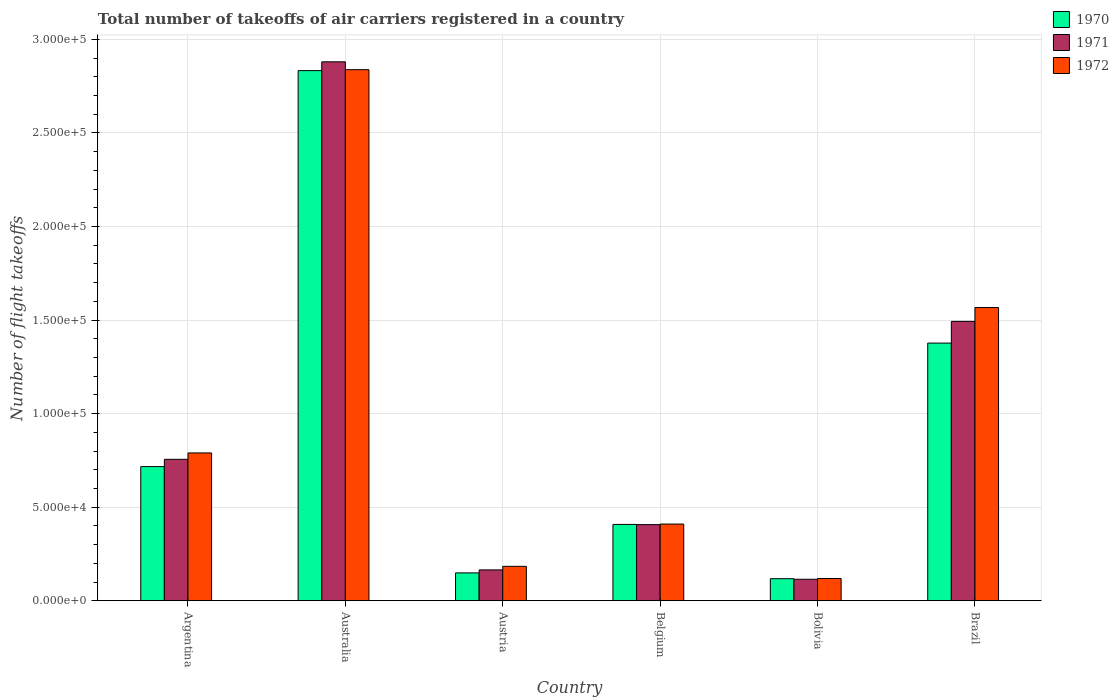How many groups of bars are there?
Your response must be concise. 6. What is the label of the 3rd group of bars from the left?
Your response must be concise. Austria. What is the total number of flight takeoffs in 1971 in Bolivia?
Offer a terse response. 1.15e+04. Across all countries, what is the maximum total number of flight takeoffs in 1970?
Offer a very short reply. 2.83e+05. Across all countries, what is the minimum total number of flight takeoffs in 1972?
Give a very brief answer. 1.19e+04. In which country was the total number of flight takeoffs in 1972 maximum?
Offer a terse response. Australia. In which country was the total number of flight takeoffs in 1971 minimum?
Provide a succinct answer. Bolivia. What is the total total number of flight takeoffs in 1972 in the graph?
Provide a short and direct response. 5.91e+05. What is the difference between the total number of flight takeoffs in 1971 in Austria and that in Brazil?
Your answer should be very brief. -1.33e+05. What is the difference between the total number of flight takeoffs in 1970 in Austria and the total number of flight takeoffs in 1971 in Belgium?
Give a very brief answer. -2.58e+04. What is the average total number of flight takeoffs in 1970 per country?
Your response must be concise. 9.34e+04. What is the difference between the total number of flight takeoffs of/in 1971 and total number of flight takeoffs of/in 1970 in Australia?
Ensure brevity in your answer.  4700. In how many countries, is the total number of flight takeoffs in 1970 greater than 260000?
Offer a very short reply. 1. What is the ratio of the total number of flight takeoffs in 1971 in Australia to that in Austria?
Make the answer very short. 17.45. Is the total number of flight takeoffs in 1971 in Austria less than that in Belgium?
Provide a short and direct response. Yes. What is the difference between the highest and the second highest total number of flight takeoffs in 1970?
Provide a succinct answer. -1.46e+05. What is the difference between the highest and the lowest total number of flight takeoffs in 1970?
Your answer should be compact. 2.72e+05. Is it the case that in every country, the sum of the total number of flight takeoffs in 1972 and total number of flight takeoffs in 1970 is greater than the total number of flight takeoffs in 1971?
Offer a very short reply. Yes. Are all the bars in the graph horizontal?
Give a very brief answer. No. Does the graph contain grids?
Offer a very short reply. Yes. Where does the legend appear in the graph?
Your answer should be compact. Top right. How many legend labels are there?
Your answer should be compact. 3. What is the title of the graph?
Provide a succinct answer. Total number of takeoffs of air carriers registered in a country. What is the label or title of the Y-axis?
Make the answer very short. Number of flight takeoffs. What is the Number of flight takeoffs in 1970 in Argentina?
Offer a terse response. 7.17e+04. What is the Number of flight takeoffs of 1971 in Argentina?
Ensure brevity in your answer.  7.56e+04. What is the Number of flight takeoffs in 1972 in Argentina?
Your response must be concise. 7.90e+04. What is the Number of flight takeoffs of 1970 in Australia?
Ensure brevity in your answer.  2.83e+05. What is the Number of flight takeoffs in 1971 in Australia?
Ensure brevity in your answer.  2.88e+05. What is the Number of flight takeoffs of 1972 in Australia?
Your response must be concise. 2.84e+05. What is the Number of flight takeoffs of 1970 in Austria?
Ensure brevity in your answer.  1.49e+04. What is the Number of flight takeoffs in 1971 in Austria?
Ensure brevity in your answer.  1.65e+04. What is the Number of flight takeoffs of 1972 in Austria?
Provide a short and direct response. 1.84e+04. What is the Number of flight takeoffs in 1970 in Belgium?
Offer a very short reply. 4.08e+04. What is the Number of flight takeoffs of 1971 in Belgium?
Provide a succinct answer. 4.07e+04. What is the Number of flight takeoffs of 1972 in Belgium?
Your response must be concise. 4.10e+04. What is the Number of flight takeoffs in 1970 in Bolivia?
Give a very brief answer. 1.18e+04. What is the Number of flight takeoffs of 1971 in Bolivia?
Keep it short and to the point. 1.15e+04. What is the Number of flight takeoffs of 1972 in Bolivia?
Offer a very short reply. 1.19e+04. What is the Number of flight takeoffs of 1970 in Brazil?
Ensure brevity in your answer.  1.38e+05. What is the Number of flight takeoffs in 1971 in Brazil?
Ensure brevity in your answer.  1.49e+05. What is the Number of flight takeoffs of 1972 in Brazil?
Your answer should be very brief. 1.57e+05. Across all countries, what is the maximum Number of flight takeoffs of 1970?
Your response must be concise. 2.83e+05. Across all countries, what is the maximum Number of flight takeoffs in 1971?
Provide a short and direct response. 2.88e+05. Across all countries, what is the maximum Number of flight takeoffs of 1972?
Provide a succinct answer. 2.84e+05. Across all countries, what is the minimum Number of flight takeoffs of 1970?
Your response must be concise. 1.18e+04. Across all countries, what is the minimum Number of flight takeoffs in 1971?
Make the answer very short. 1.15e+04. Across all countries, what is the minimum Number of flight takeoffs of 1972?
Keep it short and to the point. 1.19e+04. What is the total Number of flight takeoffs of 1970 in the graph?
Ensure brevity in your answer.  5.60e+05. What is the total Number of flight takeoffs of 1971 in the graph?
Your response must be concise. 5.82e+05. What is the total Number of flight takeoffs in 1972 in the graph?
Keep it short and to the point. 5.91e+05. What is the difference between the Number of flight takeoffs of 1970 in Argentina and that in Australia?
Your response must be concise. -2.12e+05. What is the difference between the Number of flight takeoffs of 1971 in Argentina and that in Australia?
Offer a terse response. -2.12e+05. What is the difference between the Number of flight takeoffs of 1972 in Argentina and that in Australia?
Keep it short and to the point. -2.05e+05. What is the difference between the Number of flight takeoffs of 1970 in Argentina and that in Austria?
Make the answer very short. 5.68e+04. What is the difference between the Number of flight takeoffs in 1971 in Argentina and that in Austria?
Offer a terse response. 5.91e+04. What is the difference between the Number of flight takeoffs in 1972 in Argentina and that in Austria?
Keep it short and to the point. 6.06e+04. What is the difference between the Number of flight takeoffs of 1970 in Argentina and that in Belgium?
Your answer should be very brief. 3.09e+04. What is the difference between the Number of flight takeoffs in 1971 in Argentina and that in Belgium?
Give a very brief answer. 3.49e+04. What is the difference between the Number of flight takeoffs of 1972 in Argentina and that in Belgium?
Offer a very short reply. 3.80e+04. What is the difference between the Number of flight takeoffs in 1970 in Argentina and that in Bolivia?
Make the answer very short. 5.99e+04. What is the difference between the Number of flight takeoffs of 1971 in Argentina and that in Bolivia?
Offer a very short reply. 6.41e+04. What is the difference between the Number of flight takeoffs in 1972 in Argentina and that in Bolivia?
Offer a terse response. 6.71e+04. What is the difference between the Number of flight takeoffs of 1970 in Argentina and that in Brazil?
Offer a very short reply. -6.60e+04. What is the difference between the Number of flight takeoffs in 1971 in Argentina and that in Brazil?
Provide a short and direct response. -7.37e+04. What is the difference between the Number of flight takeoffs of 1972 in Argentina and that in Brazil?
Your answer should be compact. -7.77e+04. What is the difference between the Number of flight takeoffs in 1970 in Australia and that in Austria?
Offer a very short reply. 2.68e+05. What is the difference between the Number of flight takeoffs of 1971 in Australia and that in Austria?
Your answer should be very brief. 2.72e+05. What is the difference between the Number of flight takeoffs of 1972 in Australia and that in Austria?
Your answer should be very brief. 2.65e+05. What is the difference between the Number of flight takeoffs in 1970 in Australia and that in Belgium?
Offer a terse response. 2.42e+05. What is the difference between the Number of flight takeoffs of 1971 in Australia and that in Belgium?
Offer a very short reply. 2.47e+05. What is the difference between the Number of flight takeoffs of 1972 in Australia and that in Belgium?
Make the answer very short. 2.43e+05. What is the difference between the Number of flight takeoffs in 1970 in Australia and that in Bolivia?
Offer a terse response. 2.72e+05. What is the difference between the Number of flight takeoffs in 1971 in Australia and that in Bolivia?
Your response must be concise. 2.76e+05. What is the difference between the Number of flight takeoffs in 1972 in Australia and that in Bolivia?
Your answer should be very brief. 2.72e+05. What is the difference between the Number of flight takeoffs in 1970 in Australia and that in Brazil?
Your answer should be very brief. 1.46e+05. What is the difference between the Number of flight takeoffs in 1971 in Australia and that in Brazil?
Ensure brevity in your answer.  1.39e+05. What is the difference between the Number of flight takeoffs in 1972 in Australia and that in Brazil?
Give a very brief answer. 1.27e+05. What is the difference between the Number of flight takeoffs in 1970 in Austria and that in Belgium?
Provide a succinct answer. -2.59e+04. What is the difference between the Number of flight takeoffs of 1971 in Austria and that in Belgium?
Your answer should be compact. -2.42e+04. What is the difference between the Number of flight takeoffs of 1972 in Austria and that in Belgium?
Give a very brief answer. -2.26e+04. What is the difference between the Number of flight takeoffs in 1970 in Austria and that in Bolivia?
Provide a short and direct response. 3100. What is the difference between the Number of flight takeoffs in 1971 in Austria and that in Bolivia?
Your response must be concise. 5000. What is the difference between the Number of flight takeoffs in 1972 in Austria and that in Bolivia?
Make the answer very short. 6500. What is the difference between the Number of flight takeoffs in 1970 in Austria and that in Brazil?
Your answer should be compact. -1.23e+05. What is the difference between the Number of flight takeoffs of 1971 in Austria and that in Brazil?
Your response must be concise. -1.33e+05. What is the difference between the Number of flight takeoffs in 1972 in Austria and that in Brazil?
Keep it short and to the point. -1.38e+05. What is the difference between the Number of flight takeoffs of 1970 in Belgium and that in Bolivia?
Your answer should be compact. 2.90e+04. What is the difference between the Number of flight takeoffs of 1971 in Belgium and that in Bolivia?
Your answer should be compact. 2.92e+04. What is the difference between the Number of flight takeoffs in 1972 in Belgium and that in Bolivia?
Ensure brevity in your answer.  2.91e+04. What is the difference between the Number of flight takeoffs of 1970 in Belgium and that in Brazil?
Provide a short and direct response. -9.69e+04. What is the difference between the Number of flight takeoffs of 1971 in Belgium and that in Brazil?
Provide a short and direct response. -1.09e+05. What is the difference between the Number of flight takeoffs in 1972 in Belgium and that in Brazil?
Provide a succinct answer. -1.16e+05. What is the difference between the Number of flight takeoffs of 1970 in Bolivia and that in Brazil?
Provide a short and direct response. -1.26e+05. What is the difference between the Number of flight takeoffs in 1971 in Bolivia and that in Brazil?
Provide a succinct answer. -1.38e+05. What is the difference between the Number of flight takeoffs of 1972 in Bolivia and that in Brazil?
Offer a very short reply. -1.45e+05. What is the difference between the Number of flight takeoffs of 1970 in Argentina and the Number of flight takeoffs of 1971 in Australia?
Offer a terse response. -2.16e+05. What is the difference between the Number of flight takeoffs in 1970 in Argentina and the Number of flight takeoffs in 1972 in Australia?
Make the answer very short. -2.12e+05. What is the difference between the Number of flight takeoffs of 1971 in Argentina and the Number of flight takeoffs of 1972 in Australia?
Offer a terse response. -2.08e+05. What is the difference between the Number of flight takeoffs of 1970 in Argentina and the Number of flight takeoffs of 1971 in Austria?
Keep it short and to the point. 5.52e+04. What is the difference between the Number of flight takeoffs in 1970 in Argentina and the Number of flight takeoffs in 1972 in Austria?
Your answer should be very brief. 5.33e+04. What is the difference between the Number of flight takeoffs in 1971 in Argentina and the Number of flight takeoffs in 1972 in Austria?
Offer a very short reply. 5.72e+04. What is the difference between the Number of flight takeoffs of 1970 in Argentina and the Number of flight takeoffs of 1971 in Belgium?
Provide a short and direct response. 3.10e+04. What is the difference between the Number of flight takeoffs of 1970 in Argentina and the Number of flight takeoffs of 1972 in Belgium?
Give a very brief answer. 3.07e+04. What is the difference between the Number of flight takeoffs in 1971 in Argentina and the Number of flight takeoffs in 1972 in Belgium?
Ensure brevity in your answer.  3.46e+04. What is the difference between the Number of flight takeoffs in 1970 in Argentina and the Number of flight takeoffs in 1971 in Bolivia?
Provide a succinct answer. 6.02e+04. What is the difference between the Number of flight takeoffs in 1970 in Argentina and the Number of flight takeoffs in 1972 in Bolivia?
Make the answer very short. 5.98e+04. What is the difference between the Number of flight takeoffs in 1971 in Argentina and the Number of flight takeoffs in 1972 in Bolivia?
Provide a short and direct response. 6.37e+04. What is the difference between the Number of flight takeoffs of 1970 in Argentina and the Number of flight takeoffs of 1971 in Brazil?
Keep it short and to the point. -7.76e+04. What is the difference between the Number of flight takeoffs of 1970 in Argentina and the Number of flight takeoffs of 1972 in Brazil?
Offer a terse response. -8.50e+04. What is the difference between the Number of flight takeoffs of 1971 in Argentina and the Number of flight takeoffs of 1972 in Brazil?
Give a very brief answer. -8.11e+04. What is the difference between the Number of flight takeoffs of 1970 in Australia and the Number of flight takeoffs of 1971 in Austria?
Provide a succinct answer. 2.67e+05. What is the difference between the Number of flight takeoffs of 1970 in Australia and the Number of flight takeoffs of 1972 in Austria?
Offer a terse response. 2.65e+05. What is the difference between the Number of flight takeoffs in 1971 in Australia and the Number of flight takeoffs in 1972 in Austria?
Your answer should be compact. 2.70e+05. What is the difference between the Number of flight takeoffs in 1970 in Australia and the Number of flight takeoffs in 1971 in Belgium?
Give a very brief answer. 2.43e+05. What is the difference between the Number of flight takeoffs of 1970 in Australia and the Number of flight takeoffs of 1972 in Belgium?
Give a very brief answer. 2.42e+05. What is the difference between the Number of flight takeoffs in 1971 in Australia and the Number of flight takeoffs in 1972 in Belgium?
Offer a terse response. 2.47e+05. What is the difference between the Number of flight takeoffs in 1970 in Australia and the Number of flight takeoffs in 1971 in Bolivia?
Provide a short and direct response. 2.72e+05. What is the difference between the Number of flight takeoffs of 1970 in Australia and the Number of flight takeoffs of 1972 in Bolivia?
Keep it short and to the point. 2.71e+05. What is the difference between the Number of flight takeoffs of 1971 in Australia and the Number of flight takeoffs of 1972 in Bolivia?
Offer a terse response. 2.76e+05. What is the difference between the Number of flight takeoffs of 1970 in Australia and the Number of flight takeoffs of 1971 in Brazil?
Offer a very short reply. 1.34e+05. What is the difference between the Number of flight takeoffs of 1970 in Australia and the Number of flight takeoffs of 1972 in Brazil?
Ensure brevity in your answer.  1.27e+05. What is the difference between the Number of flight takeoffs in 1971 in Australia and the Number of flight takeoffs in 1972 in Brazil?
Your response must be concise. 1.31e+05. What is the difference between the Number of flight takeoffs in 1970 in Austria and the Number of flight takeoffs in 1971 in Belgium?
Your response must be concise. -2.58e+04. What is the difference between the Number of flight takeoffs in 1970 in Austria and the Number of flight takeoffs in 1972 in Belgium?
Give a very brief answer. -2.61e+04. What is the difference between the Number of flight takeoffs in 1971 in Austria and the Number of flight takeoffs in 1972 in Belgium?
Provide a short and direct response. -2.45e+04. What is the difference between the Number of flight takeoffs in 1970 in Austria and the Number of flight takeoffs in 1971 in Bolivia?
Ensure brevity in your answer.  3400. What is the difference between the Number of flight takeoffs in 1970 in Austria and the Number of flight takeoffs in 1972 in Bolivia?
Offer a very short reply. 3000. What is the difference between the Number of flight takeoffs of 1971 in Austria and the Number of flight takeoffs of 1972 in Bolivia?
Your response must be concise. 4600. What is the difference between the Number of flight takeoffs in 1970 in Austria and the Number of flight takeoffs in 1971 in Brazil?
Your answer should be compact. -1.34e+05. What is the difference between the Number of flight takeoffs of 1970 in Austria and the Number of flight takeoffs of 1972 in Brazil?
Provide a short and direct response. -1.42e+05. What is the difference between the Number of flight takeoffs in 1971 in Austria and the Number of flight takeoffs in 1972 in Brazil?
Give a very brief answer. -1.40e+05. What is the difference between the Number of flight takeoffs in 1970 in Belgium and the Number of flight takeoffs in 1971 in Bolivia?
Ensure brevity in your answer.  2.93e+04. What is the difference between the Number of flight takeoffs of 1970 in Belgium and the Number of flight takeoffs of 1972 in Bolivia?
Make the answer very short. 2.89e+04. What is the difference between the Number of flight takeoffs in 1971 in Belgium and the Number of flight takeoffs in 1972 in Bolivia?
Offer a terse response. 2.88e+04. What is the difference between the Number of flight takeoffs in 1970 in Belgium and the Number of flight takeoffs in 1971 in Brazil?
Ensure brevity in your answer.  -1.08e+05. What is the difference between the Number of flight takeoffs of 1970 in Belgium and the Number of flight takeoffs of 1972 in Brazil?
Offer a very short reply. -1.16e+05. What is the difference between the Number of flight takeoffs of 1971 in Belgium and the Number of flight takeoffs of 1972 in Brazil?
Provide a succinct answer. -1.16e+05. What is the difference between the Number of flight takeoffs of 1970 in Bolivia and the Number of flight takeoffs of 1971 in Brazil?
Give a very brief answer. -1.38e+05. What is the difference between the Number of flight takeoffs in 1970 in Bolivia and the Number of flight takeoffs in 1972 in Brazil?
Keep it short and to the point. -1.45e+05. What is the difference between the Number of flight takeoffs in 1971 in Bolivia and the Number of flight takeoffs in 1972 in Brazil?
Keep it short and to the point. -1.45e+05. What is the average Number of flight takeoffs of 1970 per country?
Keep it short and to the point. 9.34e+04. What is the average Number of flight takeoffs in 1971 per country?
Your answer should be compact. 9.69e+04. What is the average Number of flight takeoffs of 1972 per country?
Provide a short and direct response. 9.85e+04. What is the difference between the Number of flight takeoffs in 1970 and Number of flight takeoffs in 1971 in Argentina?
Your response must be concise. -3900. What is the difference between the Number of flight takeoffs in 1970 and Number of flight takeoffs in 1972 in Argentina?
Give a very brief answer. -7300. What is the difference between the Number of flight takeoffs in 1971 and Number of flight takeoffs in 1972 in Argentina?
Give a very brief answer. -3400. What is the difference between the Number of flight takeoffs in 1970 and Number of flight takeoffs in 1971 in Australia?
Your response must be concise. -4700. What is the difference between the Number of flight takeoffs in 1970 and Number of flight takeoffs in 1972 in Australia?
Make the answer very short. -500. What is the difference between the Number of flight takeoffs in 1971 and Number of flight takeoffs in 1972 in Australia?
Provide a short and direct response. 4200. What is the difference between the Number of flight takeoffs of 1970 and Number of flight takeoffs of 1971 in Austria?
Your answer should be very brief. -1600. What is the difference between the Number of flight takeoffs in 1970 and Number of flight takeoffs in 1972 in Austria?
Your answer should be compact. -3500. What is the difference between the Number of flight takeoffs in 1971 and Number of flight takeoffs in 1972 in Austria?
Provide a short and direct response. -1900. What is the difference between the Number of flight takeoffs of 1970 and Number of flight takeoffs of 1971 in Belgium?
Your answer should be compact. 100. What is the difference between the Number of flight takeoffs of 1970 and Number of flight takeoffs of 1972 in Belgium?
Your answer should be compact. -200. What is the difference between the Number of flight takeoffs in 1971 and Number of flight takeoffs in 1972 in Belgium?
Keep it short and to the point. -300. What is the difference between the Number of flight takeoffs of 1970 and Number of flight takeoffs of 1971 in Bolivia?
Give a very brief answer. 300. What is the difference between the Number of flight takeoffs in 1970 and Number of flight takeoffs in 1972 in Bolivia?
Your answer should be compact. -100. What is the difference between the Number of flight takeoffs of 1971 and Number of flight takeoffs of 1972 in Bolivia?
Your answer should be compact. -400. What is the difference between the Number of flight takeoffs in 1970 and Number of flight takeoffs in 1971 in Brazil?
Keep it short and to the point. -1.16e+04. What is the difference between the Number of flight takeoffs of 1970 and Number of flight takeoffs of 1972 in Brazil?
Your answer should be very brief. -1.90e+04. What is the difference between the Number of flight takeoffs of 1971 and Number of flight takeoffs of 1972 in Brazil?
Your answer should be compact. -7400. What is the ratio of the Number of flight takeoffs of 1970 in Argentina to that in Australia?
Provide a succinct answer. 0.25. What is the ratio of the Number of flight takeoffs of 1971 in Argentina to that in Australia?
Provide a succinct answer. 0.26. What is the ratio of the Number of flight takeoffs of 1972 in Argentina to that in Australia?
Make the answer very short. 0.28. What is the ratio of the Number of flight takeoffs in 1970 in Argentina to that in Austria?
Provide a short and direct response. 4.81. What is the ratio of the Number of flight takeoffs of 1971 in Argentina to that in Austria?
Your response must be concise. 4.58. What is the ratio of the Number of flight takeoffs of 1972 in Argentina to that in Austria?
Your answer should be compact. 4.29. What is the ratio of the Number of flight takeoffs of 1970 in Argentina to that in Belgium?
Make the answer very short. 1.76. What is the ratio of the Number of flight takeoffs in 1971 in Argentina to that in Belgium?
Make the answer very short. 1.86. What is the ratio of the Number of flight takeoffs of 1972 in Argentina to that in Belgium?
Ensure brevity in your answer.  1.93. What is the ratio of the Number of flight takeoffs of 1970 in Argentina to that in Bolivia?
Provide a short and direct response. 6.08. What is the ratio of the Number of flight takeoffs in 1971 in Argentina to that in Bolivia?
Provide a succinct answer. 6.57. What is the ratio of the Number of flight takeoffs of 1972 in Argentina to that in Bolivia?
Your answer should be very brief. 6.64. What is the ratio of the Number of flight takeoffs of 1970 in Argentina to that in Brazil?
Provide a short and direct response. 0.52. What is the ratio of the Number of flight takeoffs in 1971 in Argentina to that in Brazil?
Provide a short and direct response. 0.51. What is the ratio of the Number of flight takeoffs in 1972 in Argentina to that in Brazil?
Keep it short and to the point. 0.5. What is the ratio of the Number of flight takeoffs in 1970 in Australia to that in Austria?
Your response must be concise. 19.01. What is the ratio of the Number of flight takeoffs of 1971 in Australia to that in Austria?
Your response must be concise. 17.45. What is the ratio of the Number of flight takeoffs of 1972 in Australia to that in Austria?
Keep it short and to the point. 15.42. What is the ratio of the Number of flight takeoffs in 1970 in Australia to that in Belgium?
Offer a terse response. 6.94. What is the ratio of the Number of flight takeoffs in 1971 in Australia to that in Belgium?
Provide a short and direct response. 7.08. What is the ratio of the Number of flight takeoffs in 1972 in Australia to that in Belgium?
Provide a short and direct response. 6.92. What is the ratio of the Number of flight takeoffs in 1970 in Australia to that in Bolivia?
Ensure brevity in your answer.  24.01. What is the ratio of the Number of flight takeoffs of 1971 in Australia to that in Bolivia?
Offer a terse response. 25.04. What is the ratio of the Number of flight takeoffs in 1972 in Australia to that in Bolivia?
Offer a terse response. 23.85. What is the ratio of the Number of flight takeoffs in 1970 in Australia to that in Brazil?
Give a very brief answer. 2.06. What is the ratio of the Number of flight takeoffs of 1971 in Australia to that in Brazil?
Keep it short and to the point. 1.93. What is the ratio of the Number of flight takeoffs of 1972 in Australia to that in Brazil?
Offer a very short reply. 1.81. What is the ratio of the Number of flight takeoffs in 1970 in Austria to that in Belgium?
Your answer should be very brief. 0.37. What is the ratio of the Number of flight takeoffs in 1971 in Austria to that in Belgium?
Provide a short and direct response. 0.41. What is the ratio of the Number of flight takeoffs in 1972 in Austria to that in Belgium?
Make the answer very short. 0.45. What is the ratio of the Number of flight takeoffs in 1970 in Austria to that in Bolivia?
Your response must be concise. 1.26. What is the ratio of the Number of flight takeoffs in 1971 in Austria to that in Bolivia?
Offer a very short reply. 1.43. What is the ratio of the Number of flight takeoffs in 1972 in Austria to that in Bolivia?
Keep it short and to the point. 1.55. What is the ratio of the Number of flight takeoffs in 1970 in Austria to that in Brazil?
Offer a terse response. 0.11. What is the ratio of the Number of flight takeoffs in 1971 in Austria to that in Brazil?
Give a very brief answer. 0.11. What is the ratio of the Number of flight takeoffs in 1972 in Austria to that in Brazil?
Give a very brief answer. 0.12. What is the ratio of the Number of flight takeoffs of 1970 in Belgium to that in Bolivia?
Provide a succinct answer. 3.46. What is the ratio of the Number of flight takeoffs of 1971 in Belgium to that in Bolivia?
Your answer should be compact. 3.54. What is the ratio of the Number of flight takeoffs of 1972 in Belgium to that in Bolivia?
Provide a short and direct response. 3.45. What is the ratio of the Number of flight takeoffs of 1970 in Belgium to that in Brazil?
Offer a terse response. 0.3. What is the ratio of the Number of flight takeoffs in 1971 in Belgium to that in Brazil?
Provide a succinct answer. 0.27. What is the ratio of the Number of flight takeoffs in 1972 in Belgium to that in Brazil?
Provide a short and direct response. 0.26. What is the ratio of the Number of flight takeoffs of 1970 in Bolivia to that in Brazil?
Provide a succinct answer. 0.09. What is the ratio of the Number of flight takeoffs in 1971 in Bolivia to that in Brazil?
Your response must be concise. 0.08. What is the ratio of the Number of flight takeoffs of 1972 in Bolivia to that in Brazil?
Your answer should be very brief. 0.08. What is the difference between the highest and the second highest Number of flight takeoffs in 1970?
Offer a very short reply. 1.46e+05. What is the difference between the highest and the second highest Number of flight takeoffs of 1971?
Give a very brief answer. 1.39e+05. What is the difference between the highest and the second highest Number of flight takeoffs in 1972?
Ensure brevity in your answer.  1.27e+05. What is the difference between the highest and the lowest Number of flight takeoffs in 1970?
Your answer should be very brief. 2.72e+05. What is the difference between the highest and the lowest Number of flight takeoffs in 1971?
Provide a succinct answer. 2.76e+05. What is the difference between the highest and the lowest Number of flight takeoffs in 1972?
Your response must be concise. 2.72e+05. 